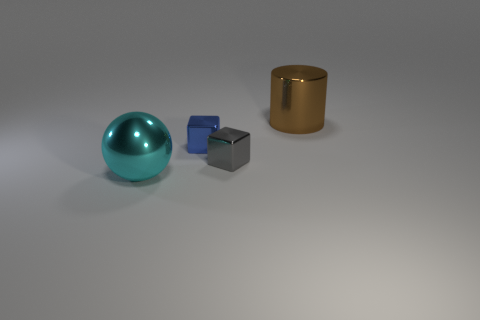What materials do the objects in the image appear to be made of? The big cyan sphere seems to have a reflective surface, suggesting it could be made of polished glass or some type of glossy plastic. The small blue and silver cube appear to be solid and metallic, hinting at a material such as steel or aluminum. The large cylindrical object has a gold-like finish, which could imply it's made either of a gold-colored metal or a metal with a gold paint finish. 